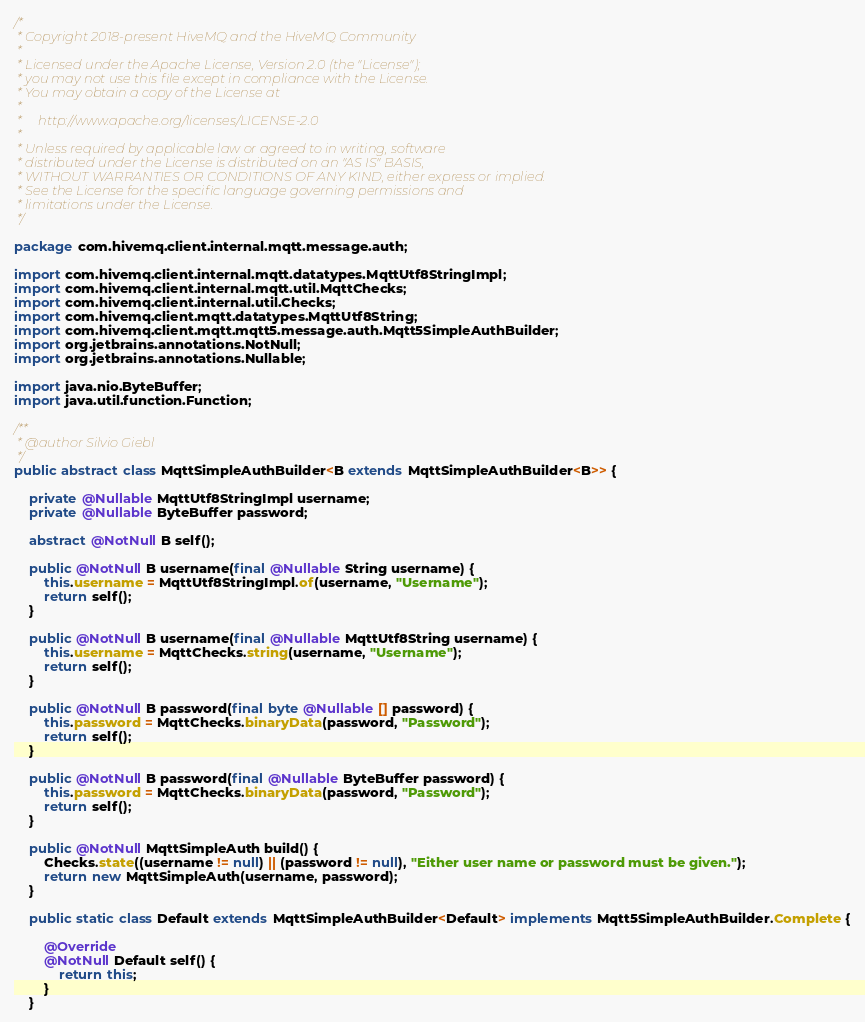<code> <loc_0><loc_0><loc_500><loc_500><_Java_>/*
 * Copyright 2018-present HiveMQ and the HiveMQ Community
 *
 * Licensed under the Apache License, Version 2.0 (the "License");
 * you may not use this file except in compliance with the License.
 * You may obtain a copy of the License at
 *
 *     http://www.apache.org/licenses/LICENSE-2.0
 *
 * Unless required by applicable law or agreed to in writing, software
 * distributed under the License is distributed on an "AS IS" BASIS,
 * WITHOUT WARRANTIES OR CONDITIONS OF ANY KIND, either express or implied.
 * See the License for the specific language governing permissions and
 * limitations under the License.
 */

package com.hivemq.client.internal.mqtt.message.auth;

import com.hivemq.client.internal.mqtt.datatypes.MqttUtf8StringImpl;
import com.hivemq.client.internal.mqtt.util.MqttChecks;
import com.hivemq.client.internal.util.Checks;
import com.hivemq.client.mqtt.datatypes.MqttUtf8String;
import com.hivemq.client.mqtt.mqtt5.message.auth.Mqtt5SimpleAuthBuilder;
import org.jetbrains.annotations.NotNull;
import org.jetbrains.annotations.Nullable;

import java.nio.ByteBuffer;
import java.util.function.Function;

/**
 * @author Silvio Giebl
 */
public abstract class MqttSimpleAuthBuilder<B extends MqttSimpleAuthBuilder<B>> {

    private @Nullable MqttUtf8StringImpl username;
    private @Nullable ByteBuffer password;

    abstract @NotNull B self();

    public @NotNull B username(final @Nullable String username) {
        this.username = MqttUtf8StringImpl.of(username, "Username");
        return self();
    }

    public @NotNull B username(final @Nullable MqttUtf8String username) {
        this.username = MqttChecks.string(username, "Username");
        return self();
    }

    public @NotNull B password(final byte @Nullable [] password) {
        this.password = MqttChecks.binaryData(password, "Password");
        return self();
    }

    public @NotNull B password(final @Nullable ByteBuffer password) {
        this.password = MqttChecks.binaryData(password, "Password");
        return self();
    }

    public @NotNull MqttSimpleAuth build() {
        Checks.state((username != null) || (password != null), "Either user name or password must be given.");
        return new MqttSimpleAuth(username, password);
    }

    public static class Default extends MqttSimpleAuthBuilder<Default> implements Mqtt5SimpleAuthBuilder.Complete {

        @Override
        @NotNull Default self() {
            return this;
        }
    }
</code> 